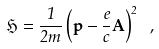Convert formula to latex. <formula><loc_0><loc_0><loc_500><loc_500>\mathfrak H = \frac { 1 } { 2 m } \left ( \mathbf p - \frac { e } { c } \mathbf A \right ) ^ { 2 } \ ,</formula> 